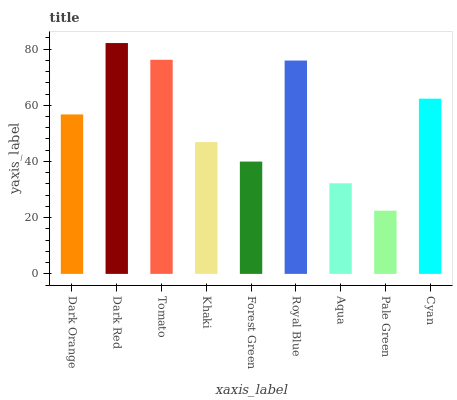Is Pale Green the minimum?
Answer yes or no. Yes. Is Dark Red the maximum?
Answer yes or no. Yes. Is Tomato the minimum?
Answer yes or no. No. Is Tomato the maximum?
Answer yes or no. No. Is Dark Red greater than Tomato?
Answer yes or no. Yes. Is Tomato less than Dark Red?
Answer yes or no. Yes. Is Tomato greater than Dark Red?
Answer yes or no. No. Is Dark Red less than Tomato?
Answer yes or no. No. Is Dark Orange the high median?
Answer yes or no. Yes. Is Dark Orange the low median?
Answer yes or no. Yes. Is Tomato the high median?
Answer yes or no. No. Is Dark Red the low median?
Answer yes or no. No. 